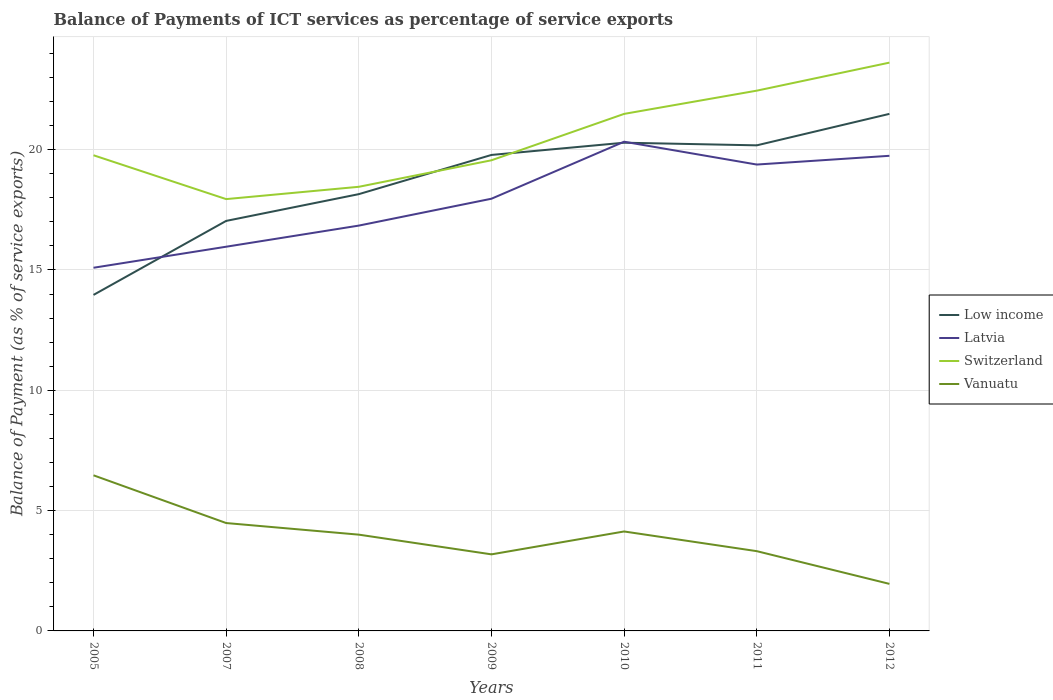Across all years, what is the maximum balance of payments of ICT services in Switzerland?
Give a very brief answer. 17.94. In which year was the balance of payments of ICT services in Latvia maximum?
Offer a very short reply. 2005. What is the total balance of payments of ICT services in Low income in the graph?
Give a very brief answer. -3.08. What is the difference between the highest and the second highest balance of payments of ICT services in Low income?
Give a very brief answer. 7.52. Is the balance of payments of ICT services in Low income strictly greater than the balance of payments of ICT services in Latvia over the years?
Offer a very short reply. No. How many lines are there?
Give a very brief answer. 4. What is the difference between two consecutive major ticks on the Y-axis?
Provide a short and direct response. 5. Are the values on the major ticks of Y-axis written in scientific E-notation?
Offer a terse response. No. Does the graph contain grids?
Your response must be concise. Yes. Where does the legend appear in the graph?
Your answer should be compact. Center right. How many legend labels are there?
Make the answer very short. 4. How are the legend labels stacked?
Your answer should be compact. Vertical. What is the title of the graph?
Provide a short and direct response. Balance of Payments of ICT services as percentage of service exports. Does "Liechtenstein" appear as one of the legend labels in the graph?
Your answer should be very brief. No. What is the label or title of the Y-axis?
Ensure brevity in your answer.  Balance of Payment (as % of service exports). What is the Balance of Payment (as % of service exports) in Low income in 2005?
Offer a very short reply. 13.96. What is the Balance of Payment (as % of service exports) in Latvia in 2005?
Offer a terse response. 15.09. What is the Balance of Payment (as % of service exports) of Switzerland in 2005?
Your response must be concise. 19.77. What is the Balance of Payment (as % of service exports) of Vanuatu in 2005?
Make the answer very short. 6.47. What is the Balance of Payment (as % of service exports) of Low income in 2007?
Make the answer very short. 17.04. What is the Balance of Payment (as % of service exports) in Latvia in 2007?
Your answer should be compact. 15.97. What is the Balance of Payment (as % of service exports) in Switzerland in 2007?
Your answer should be compact. 17.94. What is the Balance of Payment (as % of service exports) of Vanuatu in 2007?
Your answer should be compact. 4.48. What is the Balance of Payment (as % of service exports) in Low income in 2008?
Give a very brief answer. 18.15. What is the Balance of Payment (as % of service exports) of Latvia in 2008?
Ensure brevity in your answer.  16.84. What is the Balance of Payment (as % of service exports) in Switzerland in 2008?
Provide a short and direct response. 18.46. What is the Balance of Payment (as % of service exports) in Vanuatu in 2008?
Your response must be concise. 4. What is the Balance of Payment (as % of service exports) of Low income in 2009?
Ensure brevity in your answer.  19.78. What is the Balance of Payment (as % of service exports) in Latvia in 2009?
Make the answer very short. 17.96. What is the Balance of Payment (as % of service exports) of Switzerland in 2009?
Offer a very short reply. 19.56. What is the Balance of Payment (as % of service exports) of Vanuatu in 2009?
Provide a succinct answer. 3.18. What is the Balance of Payment (as % of service exports) of Low income in 2010?
Keep it short and to the point. 20.29. What is the Balance of Payment (as % of service exports) in Latvia in 2010?
Give a very brief answer. 20.33. What is the Balance of Payment (as % of service exports) of Switzerland in 2010?
Provide a succinct answer. 21.48. What is the Balance of Payment (as % of service exports) in Vanuatu in 2010?
Your answer should be compact. 4.13. What is the Balance of Payment (as % of service exports) of Low income in 2011?
Your response must be concise. 20.18. What is the Balance of Payment (as % of service exports) of Latvia in 2011?
Provide a short and direct response. 19.38. What is the Balance of Payment (as % of service exports) of Switzerland in 2011?
Give a very brief answer. 22.45. What is the Balance of Payment (as % of service exports) of Vanuatu in 2011?
Offer a terse response. 3.31. What is the Balance of Payment (as % of service exports) of Low income in 2012?
Your response must be concise. 21.49. What is the Balance of Payment (as % of service exports) of Latvia in 2012?
Your response must be concise. 19.74. What is the Balance of Payment (as % of service exports) of Switzerland in 2012?
Provide a succinct answer. 23.61. What is the Balance of Payment (as % of service exports) in Vanuatu in 2012?
Your answer should be compact. 1.96. Across all years, what is the maximum Balance of Payment (as % of service exports) of Low income?
Provide a succinct answer. 21.49. Across all years, what is the maximum Balance of Payment (as % of service exports) of Latvia?
Your answer should be very brief. 20.33. Across all years, what is the maximum Balance of Payment (as % of service exports) in Switzerland?
Ensure brevity in your answer.  23.61. Across all years, what is the maximum Balance of Payment (as % of service exports) in Vanuatu?
Offer a very short reply. 6.47. Across all years, what is the minimum Balance of Payment (as % of service exports) of Low income?
Ensure brevity in your answer.  13.96. Across all years, what is the minimum Balance of Payment (as % of service exports) in Latvia?
Your answer should be very brief. 15.09. Across all years, what is the minimum Balance of Payment (as % of service exports) of Switzerland?
Your response must be concise. 17.94. Across all years, what is the minimum Balance of Payment (as % of service exports) of Vanuatu?
Offer a terse response. 1.96. What is the total Balance of Payment (as % of service exports) of Low income in the graph?
Your answer should be compact. 130.88. What is the total Balance of Payment (as % of service exports) of Latvia in the graph?
Ensure brevity in your answer.  125.31. What is the total Balance of Payment (as % of service exports) of Switzerland in the graph?
Give a very brief answer. 143.27. What is the total Balance of Payment (as % of service exports) in Vanuatu in the graph?
Offer a terse response. 27.53. What is the difference between the Balance of Payment (as % of service exports) in Low income in 2005 and that in 2007?
Your answer should be compact. -3.08. What is the difference between the Balance of Payment (as % of service exports) in Latvia in 2005 and that in 2007?
Provide a succinct answer. -0.87. What is the difference between the Balance of Payment (as % of service exports) in Switzerland in 2005 and that in 2007?
Provide a short and direct response. 1.82. What is the difference between the Balance of Payment (as % of service exports) in Vanuatu in 2005 and that in 2007?
Keep it short and to the point. 1.98. What is the difference between the Balance of Payment (as % of service exports) in Low income in 2005 and that in 2008?
Your response must be concise. -4.19. What is the difference between the Balance of Payment (as % of service exports) of Latvia in 2005 and that in 2008?
Ensure brevity in your answer.  -1.75. What is the difference between the Balance of Payment (as % of service exports) in Switzerland in 2005 and that in 2008?
Your response must be concise. 1.31. What is the difference between the Balance of Payment (as % of service exports) of Vanuatu in 2005 and that in 2008?
Offer a terse response. 2.47. What is the difference between the Balance of Payment (as % of service exports) in Low income in 2005 and that in 2009?
Your answer should be very brief. -5.82. What is the difference between the Balance of Payment (as % of service exports) in Latvia in 2005 and that in 2009?
Make the answer very short. -2.87. What is the difference between the Balance of Payment (as % of service exports) of Switzerland in 2005 and that in 2009?
Your response must be concise. 0.21. What is the difference between the Balance of Payment (as % of service exports) in Vanuatu in 2005 and that in 2009?
Ensure brevity in your answer.  3.28. What is the difference between the Balance of Payment (as % of service exports) of Low income in 2005 and that in 2010?
Offer a terse response. -6.32. What is the difference between the Balance of Payment (as % of service exports) of Latvia in 2005 and that in 2010?
Your response must be concise. -5.24. What is the difference between the Balance of Payment (as % of service exports) in Switzerland in 2005 and that in 2010?
Give a very brief answer. -1.72. What is the difference between the Balance of Payment (as % of service exports) of Vanuatu in 2005 and that in 2010?
Make the answer very short. 2.33. What is the difference between the Balance of Payment (as % of service exports) of Low income in 2005 and that in 2011?
Make the answer very short. -6.22. What is the difference between the Balance of Payment (as % of service exports) of Latvia in 2005 and that in 2011?
Provide a short and direct response. -4.29. What is the difference between the Balance of Payment (as % of service exports) in Switzerland in 2005 and that in 2011?
Provide a short and direct response. -2.68. What is the difference between the Balance of Payment (as % of service exports) in Vanuatu in 2005 and that in 2011?
Your answer should be compact. 3.15. What is the difference between the Balance of Payment (as % of service exports) of Low income in 2005 and that in 2012?
Keep it short and to the point. -7.52. What is the difference between the Balance of Payment (as % of service exports) in Latvia in 2005 and that in 2012?
Offer a terse response. -4.65. What is the difference between the Balance of Payment (as % of service exports) of Switzerland in 2005 and that in 2012?
Make the answer very short. -3.85. What is the difference between the Balance of Payment (as % of service exports) in Vanuatu in 2005 and that in 2012?
Offer a very short reply. 4.51. What is the difference between the Balance of Payment (as % of service exports) in Low income in 2007 and that in 2008?
Keep it short and to the point. -1.11. What is the difference between the Balance of Payment (as % of service exports) of Latvia in 2007 and that in 2008?
Provide a succinct answer. -0.88. What is the difference between the Balance of Payment (as % of service exports) of Switzerland in 2007 and that in 2008?
Give a very brief answer. -0.51. What is the difference between the Balance of Payment (as % of service exports) of Vanuatu in 2007 and that in 2008?
Your answer should be compact. 0.48. What is the difference between the Balance of Payment (as % of service exports) of Low income in 2007 and that in 2009?
Give a very brief answer. -2.74. What is the difference between the Balance of Payment (as % of service exports) of Latvia in 2007 and that in 2009?
Provide a succinct answer. -1.99. What is the difference between the Balance of Payment (as % of service exports) in Switzerland in 2007 and that in 2009?
Give a very brief answer. -1.61. What is the difference between the Balance of Payment (as % of service exports) of Vanuatu in 2007 and that in 2009?
Your answer should be very brief. 1.3. What is the difference between the Balance of Payment (as % of service exports) in Low income in 2007 and that in 2010?
Make the answer very short. -3.25. What is the difference between the Balance of Payment (as % of service exports) of Latvia in 2007 and that in 2010?
Provide a succinct answer. -4.36. What is the difference between the Balance of Payment (as % of service exports) of Switzerland in 2007 and that in 2010?
Your answer should be very brief. -3.54. What is the difference between the Balance of Payment (as % of service exports) in Vanuatu in 2007 and that in 2010?
Your response must be concise. 0.35. What is the difference between the Balance of Payment (as % of service exports) of Low income in 2007 and that in 2011?
Offer a very short reply. -3.14. What is the difference between the Balance of Payment (as % of service exports) of Latvia in 2007 and that in 2011?
Provide a succinct answer. -3.41. What is the difference between the Balance of Payment (as % of service exports) in Switzerland in 2007 and that in 2011?
Provide a short and direct response. -4.51. What is the difference between the Balance of Payment (as % of service exports) in Vanuatu in 2007 and that in 2011?
Offer a terse response. 1.17. What is the difference between the Balance of Payment (as % of service exports) of Low income in 2007 and that in 2012?
Make the answer very short. -4.45. What is the difference between the Balance of Payment (as % of service exports) in Latvia in 2007 and that in 2012?
Your response must be concise. -3.78. What is the difference between the Balance of Payment (as % of service exports) in Switzerland in 2007 and that in 2012?
Ensure brevity in your answer.  -5.67. What is the difference between the Balance of Payment (as % of service exports) of Vanuatu in 2007 and that in 2012?
Give a very brief answer. 2.53. What is the difference between the Balance of Payment (as % of service exports) in Low income in 2008 and that in 2009?
Provide a short and direct response. -1.63. What is the difference between the Balance of Payment (as % of service exports) of Latvia in 2008 and that in 2009?
Offer a terse response. -1.12. What is the difference between the Balance of Payment (as % of service exports) of Switzerland in 2008 and that in 2009?
Ensure brevity in your answer.  -1.1. What is the difference between the Balance of Payment (as % of service exports) in Vanuatu in 2008 and that in 2009?
Provide a succinct answer. 0.82. What is the difference between the Balance of Payment (as % of service exports) in Low income in 2008 and that in 2010?
Make the answer very short. -2.14. What is the difference between the Balance of Payment (as % of service exports) in Latvia in 2008 and that in 2010?
Offer a terse response. -3.49. What is the difference between the Balance of Payment (as % of service exports) of Switzerland in 2008 and that in 2010?
Keep it short and to the point. -3.03. What is the difference between the Balance of Payment (as % of service exports) in Vanuatu in 2008 and that in 2010?
Your response must be concise. -0.13. What is the difference between the Balance of Payment (as % of service exports) of Low income in 2008 and that in 2011?
Your answer should be very brief. -2.03. What is the difference between the Balance of Payment (as % of service exports) of Latvia in 2008 and that in 2011?
Offer a very short reply. -2.54. What is the difference between the Balance of Payment (as % of service exports) of Switzerland in 2008 and that in 2011?
Ensure brevity in your answer.  -3.99. What is the difference between the Balance of Payment (as % of service exports) in Vanuatu in 2008 and that in 2011?
Your response must be concise. 0.69. What is the difference between the Balance of Payment (as % of service exports) of Low income in 2008 and that in 2012?
Your answer should be very brief. -3.34. What is the difference between the Balance of Payment (as % of service exports) in Latvia in 2008 and that in 2012?
Your answer should be compact. -2.9. What is the difference between the Balance of Payment (as % of service exports) in Switzerland in 2008 and that in 2012?
Offer a terse response. -5.16. What is the difference between the Balance of Payment (as % of service exports) in Vanuatu in 2008 and that in 2012?
Offer a very short reply. 2.05. What is the difference between the Balance of Payment (as % of service exports) in Low income in 2009 and that in 2010?
Keep it short and to the point. -0.51. What is the difference between the Balance of Payment (as % of service exports) of Latvia in 2009 and that in 2010?
Provide a short and direct response. -2.37. What is the difference between the Balance of Payment (as % of service exports) in Switzerland in 2009 and that in 2010?
Provide a short and direct response. -1.93. What is the difference between the Balance of Payment (as % of service exports) in Vanuatu in 2009 and that in 2010?
Offer a terse response. -0.95. What is the difference between the Balance of Payment (as % of service exports) of Low income in 2009 and that in 2011?
Your answer should be very brief. -0.4. What is the difference between the Balance of Payment (as % of service exports) in Latvia in 2009 and that in 2011?
Provide a succinct answer. -1.42. What is the difference between the Balance of Payment (as % of service exports) in Switzerland in 2009 and that in 2011?
Keep it short and to the point. -2.89. What is the difference between the Balance of Payment (as % of service exports) in Vanuatu in 2009 and that in 2011?
Offer a terse response. -0.13. What is the difference between the Balance of Payment (as % of service exports) in Low income in 2009 and that in 2012?
Keep it short and to the point. -1.71. What is the difference between the Balance of Payment (as % of service exports) of Latvia in 2009 and that in 2012?
Provide a succinct answer. -1.78. What is the difference between the Balance of Payment (as % of service exports) in Switzerland in 2009 and that in 2012?
Your response must be concise. -4.06. What is the difference between the Balance of Payment (as % of service exports) of Vanuatu in 2009 and that in 2012?
Ensure brevity in your answer.  1.23. What is the difference between the Balance of Payment (as % of service exports) of Low income in 2010 and that in 2011?
Provide a short and direct response. 0.11. What is the difference between the Balance of Payment (as % of service exports) of Latvia in 2010 and that in 2011?
Your answer should be compact. 0.95. What is the difference between the Balance of Payment (as % of service exports) of Switzerland in 2010 and that in 2011?
Keep it short and to the point. -0.97. What is the difference between the Balance of Payment (as % of service exports) of Vanuatu in 2010 and that in 2011?
Provide a short and direct response. 0.82. What is the difference between the Balance of Payment (as % of service exports) of Low income in 2010 and that in 2012?
Your answer should be very brief. -1.2. What is the difference between the Balance of Payment (as % of service exports) of Latvia in 2010 and that in 2012?
Your response must be concise. 0.59. What is the difference between the Balance of Payment (as % of service exports) in Switzerland in 2010 and that in 2012?
Provide a succinct answer. -2.13. What is the difference between the Balance of Payment (as % of service exports) in Vanuatu in 2010 and that in 2012?
Offer a very short reply. 2.18. What is the difference between the Balance of Payment (as % of service exports) in Low income in 2011 and that in 2012?
Your response must be concise. -1.31. What is the difference between the Balance of Payment (as % of service exports) in Latvia in 2011 and that in 2012?
Offer a very short reply. -0.36. What is the difference between the Balance of Payment (as % of service exports) in Switzerland in 2011 and that in 2012?
Give a very brief answer. -1.16. What is the difference between the Balance of Payment (as % of service exports) in Vanuatu in 2011 and that in 2012?
Make the answer very short. 1.36. What is the difference between the Balance of Payment (as % of service exports) of Low income in 2005 and the Balance of Payment (as % of service exports) of Latvia in 2007?
Give a very brief answer. -2. What is the difference between the Balance of Payment (as % of service exports) of Low income in 2005 and the Balance of Payment (as % of service exports) of Switzerland in 2007?
Offer a terse response. -3.98. What is the difference between the Balance of Payment (as % of service exports) in Low income in 2005 and the Balance of Payment (as % of service exports) in Vanuatu in 2007?
Provide a short and direct response. 9.48. What is the difference between the Balance of Payment (as % of service exports) in Latvia in 2005 and the Balance of Payment (as % of service exports) in Switzerland in 2007?
Your response must be concise. -2.85. What is the difference between the Balance of Payment (as % of service exports) of Latvia in 2005 and the Balance of Payment (as % of service exports) of Vanuatu in 2007?
Offer a very short reply. 10.61. What is the difference between the Balance of Payment (as % of service exports) in Switzerland in 2005 and the Balance of Payment (as % of service exports) in Vanuatu in 2007?
Ensure brevity in your answer.  15.28. What is the difference between the Balance of Payment (as % of service exports) of Low income in 2005 and the Balance of Payment (as % of service exports) of Latvia in 2008?
Give a very brief answer. -2.88. What is the difference between the Balance of Payment (as % of service exports) of Low income in 2005 and the Balance of Payment (as % of service exports) of Switzerland in 2008?
Your answer should be very brief. -4.49. What is the difference between the Balance of Payment (as % of service exports) in Low income in 2005 and the Balance of Payment (as % of service exports) in Vanuatu in 2008?
Your answer should be compact. 9.96. What is the difference between the Balance of Payment (as % of service exports) in Latvia in 2005 and the Balance of Payment (as % of service exports) in Switzerland in 2008?
Provide a short and direct response. -3.36. What is the difference between the Balance of Payment (as % of service exports) in Latvia in 2005 and the Balance of Payment (as % of service exports) in Vanuatu in 2008?
Give a very brief answer. 11.09. What is the difference between the Balance of Payment (as % of service exports) in Switzerland in 2005 and the Balance of Payment (as % of service exports) in Vanuatu in 2008?
Keep it short and to the point. 15.77. What is the difference between the Balance of Payment (as % of service exports) in Low income in 2005 and the Balance of Payment (as % of service exports) in Latvia in 2009?
Your response must be concise. -4. What is the difference between the Balance of Payment (as % of service exports) in Low income in 2005 and the Balance of Payment (as % of service exports) in Switzerland in 2009?
Make the answer very short. -5.59. What is the difference between the Balance of Payment (as % of service exports) in Low income in 2005 and the Balance of Payment (as % of service exports) in Vanuatu in 2009?
Provide a succinct answer. 10.78. What is the difference between the Balance of Payment (as % of service exports) of Latvia in 2005 and the Balance of Payment (as % of service exports) of Switzerland in 2009?
Offer a terse response. -4.47. What is the difference between the Balance of Payment (as % of service exports) in Latvia in 2005 and the Balance of Payment (as % of service exports) in Vanuatu in 2009?
Give a very brief answer. 11.91. What is the difference between the Balance of Payment (as % of service exports) of Switzerland in 2005 and the Balance of Payment (as % of service exports) of Vanuatu in 2009?
Ensure brevity in your answer.  16.58. What is the difference between the Balance of Payment (as % of service exports) in Low income in 2005 and the Balance of Payment (as % of service exports) in Latvia in 2010?
Make the answer very short. -6.37. What is the difference between the Balance of Payment (as % of service exports) in Low income in 2005 and the Balance of Payment (as % of service exports) in Switzerland in 2010?
Ensure brevity in your answer.  -7.52. What is the difference between the Balance of Payment (as % of service exports) of Low income in 2005 and the Balance of Payment (as % of service exports) of Vanuatu in 2010?
Your answer should be very brief. 9.83. What is the difference between the Balance of Payment (as % of service exports) in Latvia in 2005 and the Balance of Payment (as % of service exports) in Switzerland in 2010?
Provide a succinct answer. -6.39. What is the difference between the Balance of Payment (as % of service exports) of Latvia in 2005 and the Balance of Payment (as % of service exports) of Vanuatu in 2010?
Your response must be concise. 10.96. What is the difference between the Balance of Payment (as % of service exports) in Switzerland in 2005 and the Balance of Payment (as % of service exports) in Vanuatu in 2010?
Your answer should be compact. 15.63. What is the difference between the Balance of Payment (as % of service exports) of Low income in 2005 and the Balance of Payment (as % of service exports) of Latvia in 2011?
Offer a terse response. -5.42. What is the difference between the Balance of Payment (as % of service exports) in Low income in 2005 and the Balance of Payment (as % of service exports) in Switzerland in 2011?
Your answer should be very brief. -8.49. What is the difference between the Balance of Payment (as % of service exports) in Low income in 2005 and the Balance of Payment (as % of service exports) in Vanuatu in 2011?
Offer a terse response. 10.65. What is the difference between the Balance of Payment (as % of service exports) of Latvia in 2005 and the Balance of Payment (as % of service exports) of Switzerland in 2011?
Your answer should be compact. -7.36. What is the difference between the Balance of Payment (as % of service exports) in Latvia in 2005 and the Balance of Payment (as % of service exports) in Vanuatu in 2011?
Your answer should be compact. 11.78. What is the difference between the Balance of Payment (as % of service exports) of Switzerland in 2005 and the Balance of Payment (as % of service exports) of Vanuatu in 2011?
Offer a very short reply. 16.45. What is the difference between the Balance of Payment (as % of service exports) of Low income in 2005 and the Balance of Payment (as % of service exports) of Latvia in 2012?
Keep it short and to the point. -5.78. What is the difference between the Balance of Payment (as % of service exports) in Low income in 2005 and the Balance of Payment (as % of service exports) in Switzerland in 2012?
Your response must be concise. -9.65. What is the difference between the Balance of Payment (as % of service exports) in Low income in 2005 and the Balance of Payment (as % of service exports) in Vanuatu in 2012?
Give a very brief answer. 12.01. What is the difference between the Balance of Payment (as % of service exports) in Latvia in 2005 and the Balance of Payment (as % of service exports) in Switzerland in 2012?
Your answer should be very brief. -8.52. What is the difference between the Balance of Payment (as % of service exports) in Latvia in 2005 and the Balance of Payment (as % of service exports) in Vanuatu in 2012?
Your answer should be compact. 13.14. What is the difference between the Balance of Payment (as % of service exports) in Switzerland in 2005 and the Balance of Payment (as % of service exports) in Vanuatu in 2012?
Give a very brief answer. 17.81. What is the difference between the Balance of Payment (as % of service exports) of Low income in 2007 and the Balance of Payment (as % of service exports) of Latvia in 2008?
Offer a terse response. 0.2. What is the difference between the Balance of Payment (as % of service exports) in Low income in 2007 and the Balance of Payment (as % of service exports) in Switzerland in 2008?
Your answer should be very brief. -1.42. What is the difference between the Balance of Payment (as % of service exports) of Low income in 2007 and the Balance of Payment (as % of service exports) of Vanuatu in 2008?
Give a very brief answer. 13.04. What is the difference between the Balance of Payment (as % of service exports) of Latvia in 2007 and the Balance of Payment (as % of service exports) of Switzerland in 2008?
Provide a succinct answer. -2.49. What is the difference between the Balance of Payment (as % of service exports) in Latvia in 2007 and the Balance of Payment (as % of service exports) in Vanuatu in 2008?
Offer a very short reply. 11.96. What is the difference between the Balance of Payment (as % of service exports) in Switzerland in 2007 and the Balance of Payment (as % of service exports) in Vanuatu in 2008?
Your answer should be compact. 13.94. What is the difference between the Balance of Payment (as % of service exports) of Low income in 2007 and the Balance of Payment (as % of service exports) of Latvia in 2009?
Keep it short and to the point. -0.92. What is the difference between the Balance of Payment (as % of service exports) in Low income in 2007 and the Balance of Payment (as % of service exports) in Switzerland in 2009?
Offer a very short reply. -2.52. What is the difference between the Balance of Payment (as % of service exports) of Low income in 2007 and the Balance of Payment (as % of service exports) of Vanuatu in 2009?
Your response must be concise. 13.86. What is the difference between the Balance of Payment (as % of service exports) in Latvia in 2007 and the Balance of Payment (as % of service exports) in Switzerland in 2009?
Offer a terse response. -3.59. What is the difference between the Balance of Payment (as % of service exports) of Latvia in 2007 and the Balance of Payment (as % of service exports) of Vanuatu in 2009?
Give a very brief answer. 12.78. What is the difference between the Balance of Payment (as % of service exports) of Switzerland in 2007 and the Balance of Payment (as % of service exports) of Vanuatu in 2009?
Give a very brief answer. 14.76. What is the difference between the Balance of Payment (as % of service exports) of Low income in 2007 and the Balance of Payment (as % of service exports) of Latvia in 2010?
Provide a succinct answer. -3.29. What is the difference between the Balance of Payment (as % of service exports) in Low income in 2007 and the Balance of Payment (as % of service exports) in Switzerland in 2010?
Your answer should be compact. -4.45. What is the difference between the Balance of Payment (as % of service exports) in Low income in 2007 and the Balance of Payment (as % of service exports) in Vanuatu in 2010?
Offer a terse response. 12.91. What is the difference between the Balance of Payment (as % of service exports) in Latvia in 2007 and the Balance of Payment (as % of service exports) in Switzerland in 2010?
Your answer should be compact. -5.52. What is the difference between the Balance of Payment (as % of service exports) in Latvia in 2007 and the Balance of Payment (as % of service exports) in Vanuatu in 2010?
Your answer should be very brief. 11.83. What is the difference between the Balance of Payment (as % of service exports) of Switzerland in 2007 and the Balance of Payment (as % of service exports) of Vanuatu in 2010?
Keep it short and to the point. 13.81. What is the difference between the Balance of Payment (as % of service exports) in Low income in 2007 and the Balance of Payment (as % of service exports) in Latvia in 2011?
Your answer should be compact. -2.34. What is the difference between the Balance of Payment (as % of service exports) in Low income in 2007 and the Balance of Payment (as % of service exports) in Switzerland in 2011?
Offer a very short reply. -5.41. What is the difference between the Balance of Payment (as % of service exports) of Low income in 2007 and the Balance of Payment (as % of service exports) of Vanuatu in 2011?
Offer a very short reply. 13.72. What is the difference between the Balance of Payment (as % of service exports) of Latvia in 2007 and the Balance of Payment (as % of service exports) of Switzerland in 2011?
Offer a very short reply. -6.49. What is the difference between the Balance of Payment (as % of service exports) of Latvia in 2007 and the Balance of Payment (as % of service exports) of Vanuatu in 2011?
Give a very brief answer. 12.65. What is the difference between the Balance of Payment (as % of service exports) in Switzerland in 2007 and the Balance of Payment (as % of service exports) in Vanuatu in 2011?
Your answer should be compact. 14.63. What is the difference between the Balance of Payment (as % of service exports) in Low income in 2007 and the Balance of Payment (as % of service exports) in Latvia in 2012?
Keep it short and to the point. -2.71. What is the difference between the Balance of Payment (as % of service exports) of Low income in 2007 and the Balance of Payment (as % of service exports) of Switzerland in 2012?
Offer a very short reply. -6.58. What is the difference between the Balance of Payment (as % of service exports) of Low income in 2007 and the Balance of Payment (as % of service exports) of Vanuatu in 2012?
Your answer should be very brief. 15.08. What is the difference between the Balance of Payment (as % of service exports) of Latvia in 2007 and the Balance of Payment (as % of service exports) of Switzerland in 2012?
Keep it short and to the point. -7.65. What is the difference between the Balance of Payment (as % of service exports) in Latvia in 2007 and the Balance of Payment (as % of service exports) in Vanuatu in 2012?
Provide a short and direct response. 14.01. What is the difference between the Balance of Payment (as % of service exports) of Switzerland in 2007 and the Balance of Payment (as % of service exports) of Vanuatu in 2012?
Your answer should be compact. 15.99. What is the difference between the Balance of Payment (as % of service exports) of Low income in 2008 and the Balance of Payment (as % of service exports) of Latvia in 2009?
Make the answer very short. 0.19. What is the difference between the Balance of Payment (as % of service exports) in Low income in 2008 and the Balance of Payment (as % of service exports) in Switzerland in 2009?
Your answer should be compact. -1.41. What is the difference between the Balance of Payment (as % of service exports) in Low income in 2008 and the Balance of Payment (as % of service exports) in Vanuatu in 2009?
Provide a short and direct response. 14.97. What is the difference between the Balance of Payment (as % of service exports) in Latvia in 2008 and the Balance of Payment (as % of service exports) in Switzerland in 2009?
Your response must be concise. -2.71. What is the difference between the Balance of Payment (as % of service exports) of Latvia in 2008 and the Balance of Payment (as % of service exports) of Vanuatu in 2009?
Your answer should be compact. 13.66. What is the difference between the Balance of Payment (as % of service exports) of Switzerland in 2008 and the Balance of Payment (as % of service exports) of Vanuatu in 2009?
Keep it short and to the point. 15.27. What is the difference between the Balance of Payment (as % of service exports) in Low income in 2008 and the Balance of Payment (as % of service exports) in Latvia in 2010?
Make the answer very short. -2.18. What is the difference between the Balance of Payment (as % of service exports) of Low income in 2008 and the Balance of Payment (as % of service exports) of Switzerland in 2010?
Your response must be concise. -3.33. What is the difference between the Balance of Payment (as % of service exports) of Low income in 2008 and the Balance of Payment (as % of service exports) of Vanuatu in 2010?
Keep it short and to the point. 14.02. What is the difference between the Balance of Payment (as % of service exports) in Latvia in 2008 and the Balance of Payment (as % of service exports) in Switzerland in 2010?
Ensure brevity in your answer.  -4.64. What is the difference between the Balance of Payment (as % of service exports) in Latvia in 2008 and the Balance of Payment (as % of service exports) in Vanuatu in 2010?
Offer a very short reply. 12.71. What is the difference between the Balance of Payment (as % of service exports) in Switzerland in 2008 and the Balance of Payment (as % of service exports) in Vanuatu in 2010?
Offer a terse response. 14.32. What is the difference between the Balance of Payment (as % of service exports) in Low income in 2008 and the Balance of Payment (as % of service exports) in Latvia in 2011?
Give a very brief answer. -1.23. What is the difference between the Balance of Payment (as % of service exports) of Low income in 2008 and the Balance of Payment (as % of service exports) of Vanuatu in 2011?
Give a very brief answer. 14.84. What is the difference between the Balance of Payment (as % of service exports) in Latvia in 2008 and the Balance of Payment (as % of service exports) in Switzerland in 2011?
Give a very brief answer. -5.61. What is the difference between the Balance of Payment (as % of service exports) in Latvia in 2008 and the Balance of Payment (as % of service exports) in Vanuatu in 2011?
Keep it short and to the point. 13.53. What is the difference between the Balance of Payment (as % of service exports) in Switzerland in 2008 and the Balance of Payment (as % of service exports) in Vanuatu in 2011?
Your answer should be very brief. 15.14. What is the difference between the Balance of Payment (as % of service exports) in Low income in 2008 and the Balance of Payment (as % of service exports) in Latvia in 2012?
Your response must be concise. -1.59. What is the difference between the Balance of Payment (as % of service exports) in Low income in 2008 and the Balance of Payment (as % of service exports) in Switzerland in 2012?
Offer a very short reply. -5.46. What is the difference between the Balance of Payment (as % of service exports) in Low income in 2008 and the Balance of Payment (as % of service exports) in Vanuatu in 2012?
Offer a terse response. 16.2. What is the difference between the Balance of Payment (as % of service exports) of Latvia in 2008 and the Balance of Payment (as % of service exports) of Switzerland in 2012?
Your response must be concise. -6.77. What is the difference between the Balance of Payment (as % of service exports) in Latvia in 2008 and the Balance of Payment (as % of service exports) in Vanuatu in 2012?
Provide a succinct answer. 14.89. What is the difference between the Balance of Payment (as % of service exports) of Switzerland in 2008 and the Balance of Payment (as % of service exports) of Vanuatu in 2012?
Ensure brevity in your answer.  16.5. What is the difference between the Balance of Payment (as % of service exports) in Low income in 2009 and the Balance of Payment (as % of service exports) in Latvia in 2010?
Offer a very short reply. -0.55. What is the difference between the Balance of Payment (as % of service exports) in Low income in 2009 and the Balance of Payment (as % of service exports) in Switzerland in 2010?
Offer a terse response. -1.71. What is the difference between the Balance of Payment (as % of service exports) in Low income in 2009 and the Balance of Payment (as % of service exports) in Vanuatu in 2010?
Provide a short and direct response. 15.65. What is the difference between the Balance of Payment (as % of service exports) in Latvia in 2009 and the Balance of Payment (as % of service exports) in Switzerland in 2010?
Your answer should be very brief. -3.52. What is the difference between the Balance of Payment (as % of service exports) in Latvia in 2009 and the Balance of Payment (as % of service exports) in Vanuatu in 2010?
Give a very brief answer. 13.83. What is the difference between the Balance of Payment (as % of service exports) of Switzerland in 2009 and the Balance of Payment (as % of service exports) of Vanuatu in 2010?
Your answer should be compact. 15.42. What is the difference between the Balance of Payment (as % of service exports) of Low income in 2009 and the Balance of Payment (as % of service exports) of Latvia in 2011?
Offer a terse response. 0.4. What is the difference between the Balance of Payment (as % of service exports) of Low income in 2009 and the Balance of Payment (as % of service exports) of Switzerland in 2011?
Your response must be concise. -2.67. What is the difference between the Balance of Payment (as % of service exports) in Low income in 2009 and the Balance of Payment (as % of service exports) in Vanuatu in 2011?
Provide a short and direct response. 16.46. What is the difference between the Balance of Payment (as % of service exports) of Latvia in 2009 and the Balance of Payment (as % of service exports) of Switzerland in 2011?
Provide a succinct answer. -4.49. What is the difference between the Balance of Payment (as % of service exports) in Latvia in 2009 and the Balance of Payment (as % of service exports) in Vanuatu in 2011?
Your answer should be compact. 14.65. What is the difference between the Balance of Payment (as % of service exports) of Switzerland in 2009 and the Balance of Payment (as % of service exports) of Vanuatu in 2011?
Give a very brief answer. 16.24. What is the difference between the Balance of Payment (as % of service exports) in Low income in 2009 and the Balance of Payment (as % of service exports) in Latvia in 2012?
Provide a succinct answer. 0.04. What is the difference between the Balance of Payment (as % of service exports) of Low income in 2009 and the Balance of Payment (as % of service exports) of Switzerland in 2012?
Your answer should be very brief. -3.84. What is the difference between the Balance of Payment (as % of service exports) of Low income in 2009 and the Balance of Payment (as % of service exports) of Vanuatu in 2012?
Your answer should be compact. 17.82. What is the difference between the Balance of Payment (as % of service exports) of Latvia in 2009 and the Balance of Payment (as % of service exports) of Switzerland in 2012?
Make the answer very short. -5.65. What is the difference between the Balance of Payment (as % of service exports) of Latvia in 2009 and the Balance of Payment (as % of service exports) of Vanuatu in 2012?
Offer a very short reply. 16. What is the difference between the Balance of Payment (as % of service exports) in Switzerland in 2009 and the Balance of Payment (as % of service exports) in Vanuatu in 2012?
Provide a succinct answer. 17.6. What is the difference between the Balance of Payment (as % of service exports) in Low income in 2010 and the Balance of Payment (as % of service exports) in Latvia in 2011?
Provide a succinct answer. 0.91. What is the difference between the Balance of Payment (as % of service exports) in Low income in 2010 and the Balance of Payment (as % of service exports) in Switzerland in 2011?
Ensure brevity in your answer.  -2.16. What is the difference between the Balance of Payment (as % of service exports) of Low income in 2010 and the Balance of Payment (as % of service exports) of Vanuatu in 2011?
Provide a short and direct response. 16.97. What is the difference between the Balance of Payment (as % of service exports) in Latvia in 2010 and the Balance of Payment (as % of service exports) in Switzerland in 2011?
Offer a very short reply. -2.12. What is the difference between the Balance of Payment (as % of service exports) in Latvia in 2010 and the Balance of Payment (as % of service exports) in Vanuatu in 2011?
Your response must be concise. 17.01. What is the difference between the Balance of Payment (as % of service exports) of Switzerland in 2010 and the Balance of Payment (as % of service exports) of Vanuatu in 2011?
Offer a very short reply. 18.17. What is the difference between the Balance of Payment (as % of service exports) in Low income in 2010 and the Balance of Payment (as % of service exports) in Latvia in 2012?
Your answer should be compact. 0.54. What is the difference between the Balance of Payment (as % of service exports) of Low income in 2010 and the Balance of Payment (as % of service exports) of Switzerland in 2012?
Keep it short and to the point. -3.33. What is the difference between the Balance of Payment (as % of service exports) in Low income in 2010 and the Balance of Payment (as % of service exports) in Vanuatu in 2012?
Offer a terse response. 18.33. What is the difference between the Balance of Payment (as % of service exports) in Latvia in 2010 and the Balance of Payment (as % of service exports) in Switzerland in 2012?
Your response must be concise. -3.29. What is the difference between the Balance of Payment (as % of service exports) of Latvia in 2010 and the Balance of Payment (as % of service exports) of Vanuatu in 2012?
Provide a succinct answer. 18.37. What is the difference between the Balance of Payment (as % of service exports) in Switzerland in 2010 and the Balance of Payment (as % of service exports) in Vanuatu in 2012?
Offer a very short reply. 19.53. What is the difference between the Balance of Payment (as % of service exports) in Low income in 2011 and the Balance of Payment (as % of service exports) in Latvia in 2012?
Give a very brief answer. 0.43. What is the difference between the Balance of Payment (as % of service exports) of Low income in 2011 and the Balance of Payment (as % of service exports) of Switzerland in 2012?
Ensure brevity in your answer.  -3.44. What is the difference between the Balance of Payment (as % of service exports) of Low income in 2011 and the Balance of Payment (as % of service exports) of Vanuatu in 2012?
Keep it short and to the point. 18.22. What is the difference between the Balance of Payment (as % of service exports) of Latvia in 2011 and the Balance of Payment (as % of service exports) of Switzerland in 2012?
Your response must be concise. -4.23. What is the difference between the Balance of Payment (as % of service exports) in Latvia in 2011 and the Balance of Payment (as % of service exports) in Vanuatu in 2012?
Offer a very short reply. 17.43. What is the difference between the Balance of Payment (as % of service exports) of Switzerland in 2011 and the Balance of Payment (as % of service exports) of Vanuatu in 2012?
Make the answer very short. 20.5. What is the average Balance of Payment (as % of service exports) in Low income per year?
Your answer should be compact. 18.7. What is the average Balance of Payment (as % of service exports) of Latvia per year?
Offer a terse response. 17.9. What is the average Balance of Payment (as % of service exports) in Switzerland per year?
Keep it short and to the point. 20.47. What is the average Balance of Payment (as % of service exports) of Vanuatu per year?
Your response must be concise. 3.93. In the year 2005, what is the difference between the Balance of Payment (as % of service exports) in Low income and Balance of Payment (as % of service exports) in Latvia?
Offer a terse response. -1.13. In the year 2005, what is the difference between the Balance of Payment (as % of service exports) of Low income and Balance of Payment (as % of service exports) of Switzerland?
Your answer should be compact. -5.8. In the year 2005, what is the difference between the Balance of Payment (as % of service exports) of Low income and Balance of Payment (as % of service exports) of Vanuatu?
Offer a terse response. 7.5. In the year 2005, what is the difference between the Balance of Payment (as % of service exports) in Latvia and Balance of Payment (as % of service exports) in Switzerland?
Ensure brevity in your answer.  -4.67. In the year 2005, what is the difference between the Balance of Payment (as % of service exports) in Latvia and Balance of Payment (as % of service exports) in Vanuatu?
Provide a succinct answer. 8.63. In the year 2005, what is the difference between the Balance of Payment (as % of service exports) in Switzerland and Balance of Payment (as % of service exports) in Vanuatu?
Offer a terse response. 13.3. In the year 2007, what is the difference between the Balance of Payment (as % of service exports) of Low income and Balance of Payment (as % of service exports) of Latvia?
Make the answer very short. 1.07. In the year 2007, what is the difference between the Balance of Payment (as % of service exports) in Low income and Balance of Payment (as % of service exports) in Switzerland?
Offer a terse response. -0.91. In the year 2007, what is the difference between the Balance of Payment (as % of service exports) of Low income and Balance of Payment (as % of service exports) of Vanuatu?
Keep it short and to the point. 12.56. In the year 2007, what is the difference between the Balance of Payment (as % of service exports) in Latvia and Balance of Payment (as % of service exports) in Switzerland?
Keep it short and to the point. -1.98. In the year 2007, what is the difference between the Balance of Payment (as % of service exports) of Latvia and Balance of Payment (as % of service exports) of Vanuatu?
Keep it short and to the point. 11.48. In the year 2007, what is the difference between the Balance of Payment (as % of service exports) in Switzerland and Balance of Payment (as % of service exports) in Vanuatu?
Offer a very short reply. 13.46. In the year 2008, what is the difference between the Balance of Payment (as % of service exports) in Low income and Balance of Payment (as % of service exports) in Latvia?
Ensure brevity in your answer.  1.31. In the year 2008, what is the difference between the Balance of Payment (as % of service exports) in Low income and Balance of Payment (as % of service exports) in Switzerland?
Keep it short and to the point. -0.31. In the year 2008, what is the difference between the Balance of Payment (as % of service exports) in Low income and Balance of Payment (as % of service exports) in Vanuatu?
Provide a short and direct response. 14.15. In the year 2008, what is the difference between the Balance of Payment (as % of service exports) of Latvia and Balance of Payment (as % of service exports) of Switzerland?
Your response must be concise. -1.61. In the year 2008, what is the difference between the Balance of Payment (as % of service exports) in Latvia and Balance of Payment (as % of service exports) in Vanuatu?
Keep it short and to the point. 12.84. In the year 2008, what is the difference between the Balance of Payment (as % of service exports) in Switzerland and Balance of Payment (as % of service exports) in Vanuatu?
Keep it short and to the point. 14.46. In the year 2009, what is the difference between the Balance of Payment (as % of service exports) of Low income and Balance of Payment (as % of service exports) of Latvia?
Provide a short and direct response. 1.82. In the year 2009, what is the difference between the Balance of Payment (as % of service exports) in Low income and Balance of Payment (as % of service exports) in Switzerland?
Make the answer very short. 0.22. In the year 2009, what is the difference between the Balance of Payment (as % of service exports) of Low income and Balance of Payment (as % of service exports) of Vanuatu?
Offer a terse response. 16.6. In the year 2009, what is the difference between the Balance of Payment (as % of service exports) in Latvia and Balance of Payment (as % of service exports) in Switzerland?
Your response must be concise. -1.6. In the year 2009, what is the difference between the Balance of Payment (as % of service exports) in Latvia and Balance of Payment (as % of service exports) in Vanuatu?
Your response must be concise. 14.78. In the year 2009, what is the difference between the Balance of Payment (as % of service exports) in Switzerland and Balance of Payment (as % of service exports) in Vanuatu?
Keep it short and to the point. 16.38. In the year 2010, what is the difference between the Balance of Payment (as % of service exports) in Low income and Balance of Payment (as % of service exports) in Latvia?
Ensure brevity in your answer.  -0.04. In the year 2010, what is the difference between the Balance of Payment (as % of service exports) in Low income and Balance of Payment (as % of service exports) in Switzerland?
Provide a succinct answer. -1.2. In the year 2010, what is the difference between the Balance of Payment (as % of service exports) in Low income and Balance of Payment (as % of service exports) in Vanuatu?
Keep it short and to the point. 16.16. In the year 2010, what is the difference between the Balance of Payment (as % of service exports) of Latvia and Balance of Payment (as % of service exports) of Switzerland?
Provide a succinct answer. -1.16. In the year 2010, what is the difference between the Balance of Payment (as % of service exports) in Latvia and Balance of Payment (as % of service exports) in Vanuatu?
Your answer should be compact. 16.2. In the year 2010, what is the difference between the Balance of Payment (as % of service exports) of Switzerland and Balance of Payment (as % of service exports) of Vanuatu?
Keep it short and to the point. 17.35. In the year 2011, what is the difference between the Balance of Payment (as % of service exports) of Low income and Balance of Payment (as % of service exports) of Latvia?
Give a very brief answer. 0.8. In the year 2011, what is the difference between the Balance of Payment (as % of service exports) in Low income and Balance of Payment (as % of service exports) in Switzerland?
Offer a terse response. -2.27. In the year 2011, what is the difference between the Balance of Payment (as % of service exports) in Low income and Balance of Payment (as % of service exports) in Vanuatu?
Provide a succinct answer. 16.86. In the year 2011, what is the difference between the Balance of Payment (as % of service exports) of Latvia and Balance of Payment (as % of service exports) of Switzerland?
Your answer should be compact. -3.07. In the year 2011, what is the difference between the Balance of Payment (as % of service exports) in Latvia and Balance of Payment (as % of service exports) in Vanuatu?
Keep it short and to the point. 16.07. In the year 2011, what is the difference between the Balance of Payment (as % of service exports) of Switzerland and Balance of Payment (as % of service exports) of Vanuatu?
Give a very brief answer. 19.14. In the year 2012, what is the difference between the Balance of Payment (as % of service exports) of Low income and Balance of Payment (as % of service exports) of Latvia?
Provide a short and direct response. 1.74. In the year 2012, what is the difference between the Balance of Payment (as % of service exports) in Low income and Balance of Payment (as % of service exports) in Switzerland?
Keep it short and to the point. -2.13. In the year 2012, what is the difference between the Balance of Payment (as % of service exports) in Low income and Balance of Payment (as % of service exports) in Vanuatu?
Keep it short and to the point. 19.53. In the year 2012, what is the difference between the Balance of Payment (as % of service exports) in Latvia and Balance of Payment (as % of service exports) in Switzerland?
Keep it short and to the point. -3.87. In the year 2012, what is the difference between the Balance of Payment (as % of service exports) of Latvia and Balance of Payment (as % of service exports) of Vanuatu?
Provide a short and direct response. 17.79. In the year 2012, what is the difference between the Balance of Payment (as % of service exports) in Switzerland and Balance of Payment (as % of service exports) in Vanuatu?
Offer a terse response. 21.66. What is the ratio of the Balance of Payment (as % of service exports) of Low income in 2005 to that in 2007?
Give a very brief answer. 0.82. What is the ratio of the Balance of Payment (as % of service exports) in Latvia in 2005 to that in 2007?
Your response must be concise. 0.95. What is the ratio of the Balance of Payment (as % of service exports) in Switzerland in 2005 to that in 2007?
Offer a terse response. 1.1. What is the ratio of the Balance of Payment (as % of service exports) in Vanuatu in 2005 to that in 2007?
Keep it short and to the point. 1.44. What is the ratio of the Balance of Payment (as % of service exports) of Low income in 2005 to that in 2008?
Offer a terse response. 0.77. What is the ratio of the Balance of Payment (as % of service exports) in Latvia in 2005 to that in 2008?
Your answer should be very brief. 0.9. What is the ratio of the Balance of Payment (as % of service exports) in Switzerland in 2005 to that in 2008?
Provide a succinct answer. 1.07. What is the ratio of the Balance of Payment (as % of service exports) in Vanuatu in 2005 to that in 2008?
Offer a very short reply. 1.62. What is the ratio of the Balance of Payment (as % of service exports) in Low income in 2005 to that in 2009?
Offer a very short reply. 0.71. What is the ratio of the Balance of Payment (as % of service exports) in Latvia in 2005 to that in 2009?
Offer a very short reply. 0.84. What is the ratio of the Balance of Payment (as % of service exports) of Switzerland in 2005 to that in 2009?
Your answer should be compact. 1.01. What is the ratio of the Balance of Payment (as % of service exports) of Vanuatu in 2005 to that in 2009?
Your response must be concise. 2.03. What is the ratio of the Balance of Payment (as % of service exports) in Low income in 2005 to that in 2010?
Give a very brief answer. 0.69. What is the ratio of the Balance of Payment (as % of service exports) of Latvia in 2005 to that in 2010?
Provide a short and direct response. 0.74. What is the ratio of the Balance of Payment (as % of service exports) in Vanuatu in 2005 to that in 2010?
Your answer should be compact. 1.56. What is the ratio of the Balance of Payment (as % of service exports) of Low income in 2005 to that in 2011?
Keep it short and to the point. 0.69. What is the ratio of the Balance of Payment (as % of service exports) in Latvia in 2005 to that in 2011?
Provide a succinct answer. 0.78. What is the ratio of the Balance of Payment (as % of service exports) of Switzerland in 2005 to that in 2011?
Your response must be concise. 0.88. What is the ratio of the Balance of Payment (as % of service exports) of Vanuatu in 2005 to that in 2011?
Make the answer very short. 1.95. What is the ratio of the Balance of Payment (as % of service exports) of Low income in 2005 to that in 2012?
Give a very brief answer. 0.65. What is the ratio of the Balance of Payment (as % of service exports) of Latvia in 2005 to that in 2012?
Provide a short and direct response. 0.76. What is the ratio of the Balance of Payment (as % of service exports) in Switzerland in 2005 to that in 2012?
Your answer should be compact. 0.84. What is the ratio of the Balance of Payment (as % of service exports) in Vanuatu in 2005 to that in 2012?
Give a very brief answer. 3.31. What is the ratio of the Balance of Payment (as % of service exports) of Low income in 2007 to that in 2008?
Offer a very short reply. 0.94. What is the ratio of the Balance of Payment (as % of service exports) in Latvia in 2007 to that in 2008?
Your answer should be very brief. 0.95. What is the ratio of the Balance of Payment (as % of service exports) in Switzerland in 2007 to that in 2008?
Offer a terse response. 0.97. What is the ratio of the Balance of Payment (as % of service exports) in Vanuatu in 2007 to that in 2008?
Make the answer very short. 1.12. What is the ratio of the Balance of Payment (as % of service exports) in Low income in 2007 to that in 2009?
Make the answer very short. 0.86. What is the ratio of the Balance of Payment (as % of service exports) of Latvia in 2007 to that in 2009?
Your response must be concise. 0.89. What is the ratio of the Balance of Payment (as % of service exports) in Switzerland in 2007 to that in 2009?
Your answer should be very brief. 0.92. What is the ratio of the Balance of Payment (as % of service exports) of Vanuatu in 2007 to that in 2009?
Ensure brevity in your answer.  1.41. What is the ratio of the Balance of Payment (as % of service exports) of Low income in 2007 to that in 2010?
Your answer should be very brief. 0.84. What is the ratio of the Balance of Payment (as % of service exports) of Latvia in 2007 to that in 2010?
Your answer should be very brief. 0.79. What is the ratio of the Balance of Payment (as % of service exports) of Switzerland in 2007 to that in 2010?
Your answer should be very brief. 0.84. What is the ratio of the Balance of Payment (as % of service exports) in Vanuatu in 2007 to that in 2010?
Keep it short and to the point. 1.08. What is the ratio of the Balance of Payment (as % of service exports) of Low income in 2007 to that in 2011?
Your answer should be compact. 0.84. What is the ratio of the Balance of Payment (as % of service exports) in Latvia in 2007 to that in 2011?
Provide a succinct answer. 0.82. What is the ratio of the Balance of Payment (as % of service exports) of Switzerland in 2007 to that in 2011?
Provide a short and direct response. 0.8. What is the ratio of the Balance of Payment (as % of service exports) of Vanuatu in 2007 to that in 2011?
Offer a very short reply. 1.35. What is the ratio of the Balance of Payment (as % of service exports) of Low income in 2007 to that in 2012?
Provide a succinct answer. 0.79. What is the ratio of the Balance of Payment (as % of service exports) in Latvia in 2007 to that in 2012?
Your answer should be compact. 0.81. What is the ratio of the Balance of Payment (as % of service exports) in Switzerland in 2007 to that in 2012?
Ensure brevity in your answer.  0.76. What is the ratio of the Balance of Payment (as % of service exports) of Vanuatu in 2007 to that in 2012?
Your response must be concise. 2.29. What is the ratio of the Balance of Payment (as % of service exports) in Low income in 2008 to that in 2009?
Offer a terse response. 0.92. What is the ratio of the Balance of Payment (as % of service exports) in Latvia in 2008 to that in 2009?
Your response must be concise. 0.94. What is the ratio of the Balance of Payment (as % of service exports) of Switzerland in 2008 to that in 2009?
Give a very brief answer. 0.94. What is the ratio of the Balance of Payment (as % of service exports) in Vanuatu in 2008 to that in 2009?
Give a very brief answer. 1.26. What is the ratio of the Balance of Payment (as % of service exports) in Low income in 2008 to that in 2010?
Your answer should be very brief. 0.89. What is the ratio of the Balance of Payment (as % of service exports) in Latvia in 2008 to that in 2010?
Offer a terse response. 0.83. What is the ratio of the Balance of Payment (as % of service exports) in Switzerland in 2008 to that in 2010?
Offer a terse response. 0.86. What is the ratio of the Balance of Payment (as % of service exports) in Vanuatu in 2008 to that in 2010?
Provide a short and direct response. 0.97. What is the ratio of the Balance of Payment (as % of service exports) in Low income in 2008 to that in 2011?
Your answer should be compact. 0.9. What is the ratio of the Balance of Payment (as % of service exports) of Latvia in 2008 to that in 2011?
Your answer should be compact. 0.87. What is the ratio of the Balance of Payment (as % of service exports) of Switzerland in 2008 to that in 2011?
Ensure brevity in your answer.  0.82. What is the ratio of the Balance of Payment (as % of service exports) of Vanuatu in 2008 to that in 2011?
Your response must be concise. 1.21. What is the ratio of the Balance of Payment (as % of service exports) of Low income in 2008 to that in 2012?
Keep it short and to the point. 0.84. What is the ratio of the Balance of Payment (as % of service exports) in Latvia in 2008 to that in 2012?
Provide a succinct answer. 0.85. What is the ratio of the Balance of Payment (as % of service exports) in Switzerland in 2008 to that in 2012?
Give a very brief answer. 0.78. What is the ratio of the Balance of Payment (as % of service exports) of Vanuatu in 2008 to that in 2012?
Ensure brevity in your answer.  2.05. What is the ratio of the Balance of Payment (as % of service exports) of Low income in 2009 to that in 2010?
Offer a terse response. 0.97. What is the ratio of the Balance of Payment (as % of service exports) of Latvia in 2009 to that in 2010?
Your answer should be compact. 0.88. What is the ratio of the Balance of Payment (as % of service exports) of Switzerland in 2009 to that in 2010?
Ensure brevity in your answer.  0.91. What is the ratio of the Balance of Payment (as % of service exports) of Vanuatu in 2009 to that in 2010?
Your answer should be compact. 0.77. What is the ratio of the Balance of Payment (as % of service exports) in Low income in 2009 to that in 2011?
Give a very brief answer. 0.98. What is the ratio of the Balance of Payment (as % of service exports) in Latvia in 2009 to that in 2011?
Your answer should be compact. 0.93. What is the ratio of the Balance of Payment (as % of service exports) of Switzerland in 2009 to that in 2011?
Provide a short and direct response. 0.87. What is the ratio of the Balance of Payment (as % of service exports) of Vanuatu in 2009 to that in 2011?
Your answer should be very brief. 0.96. What is the ratio of the Balance of Payment (as % of service exports) of Low income in 2009 to that in 2012?
Give a very brief answer. 0.92. What is the ratio of the Balance of Payment (as % of service exports) in Latvia in 2009 to that in 2012?
Keep it short and to the point. 0.91. What is the ratio of the Balance of Payment (as % of service exports) in Switzerland in 2009 to that in 2012?
Your answer should be compact. 0.83. What is the ratio of the Balance of Payment (as % of service exports) in Vanuatu in 2009 to that in 2012?
Your response must be concise. 1.63. What is the ratio of the Balance of Payment (as % of service exports) in Low income in 2010 to that in 2011?
Your answer should be compact. 1.01. What is the ratio of the Balance of Payment (as % of service exports) in Latvia in 2010 to that in 2011?
Keep it short and to the point. 1.05. What is the ratio of the Balance of Payment (as % of service exports) in Vanuatu in 2010 to that in 2011?
Provide a succinct answer. 1.25. What is the ratio of the Balance of Payment (as % of service exports) of Low income in 2010 to that in 2012?
Your answer should be very brief. 0.94. What is the ratio of the Balance of Payment (as % of service exports) in Latvia in 2010 to that in 2012?
Ensure brevity in your answer.  1.03. What is the ratio of the Balance of Payment (as % of service exports) of Switzerland in 2010 to that in 2012?
Give a very brief answer. 0.91. What is the ratio of the Balance of Payment (as % of service exports) of Vanuatu in 2010 to that in 2012?
Offer a very short reply. 2.11. What is the ratio of the Balance of Payment (as % of service exports) in Low income in 2011 to that in 2012?
Give a very brief answer. 0.94. What is the ratio of the Balance of Payment (as % of service exports) of Latvia in 2011 to that in 2012?
Make the answer very short. 0.98. What is the ratio of the Balance of Payment (as % of service exports) of Switzerland in 2011 to that in 2012?
Your answer should be compact. 0.95. What is the ratio of the Balance of Payment (as % of service exports) of Vanuatu in 2011 to that in 2012?
Your answer should be compact. 1.7. What is the difference between the highest and the second highest Balance of Payment (as % of service exports) in Low income?
Ensure brevity in your answer.  1.2. What is the difference between the highest and the second highest Balance of Payment (as % of service exports) of Latvia?
Ensure brevity in your answer.  0.59. What is the difference between the highest and the second highest Balance of Payment (as % of service exports) in Switzerland?
Your answer should be very brief. 1.16. What is the difference between the highest and the second highest Balance of Payment (as % of service exports) of Vanuatu?
Your answer should be very brief. 1.98. What is the difference between the highest and the lowest Balance of Payment (as % of service exports) in Low income?
Offer a very short reply. 7.52. What is the difference between the highest and the lowest Balance of Payment (as % of service exports) in Latvia?
Your answer should be compact. 5.24. What is the difference between the highest and the lowest Balance of Payment (as % of service exports) of Switzerland?
Offer a terse response. 5.67. What is the difference between the highest and the lowest Balance of Payment (as % of service exports) of Vanuatu?
Keep it short and to the point. 4.51. 